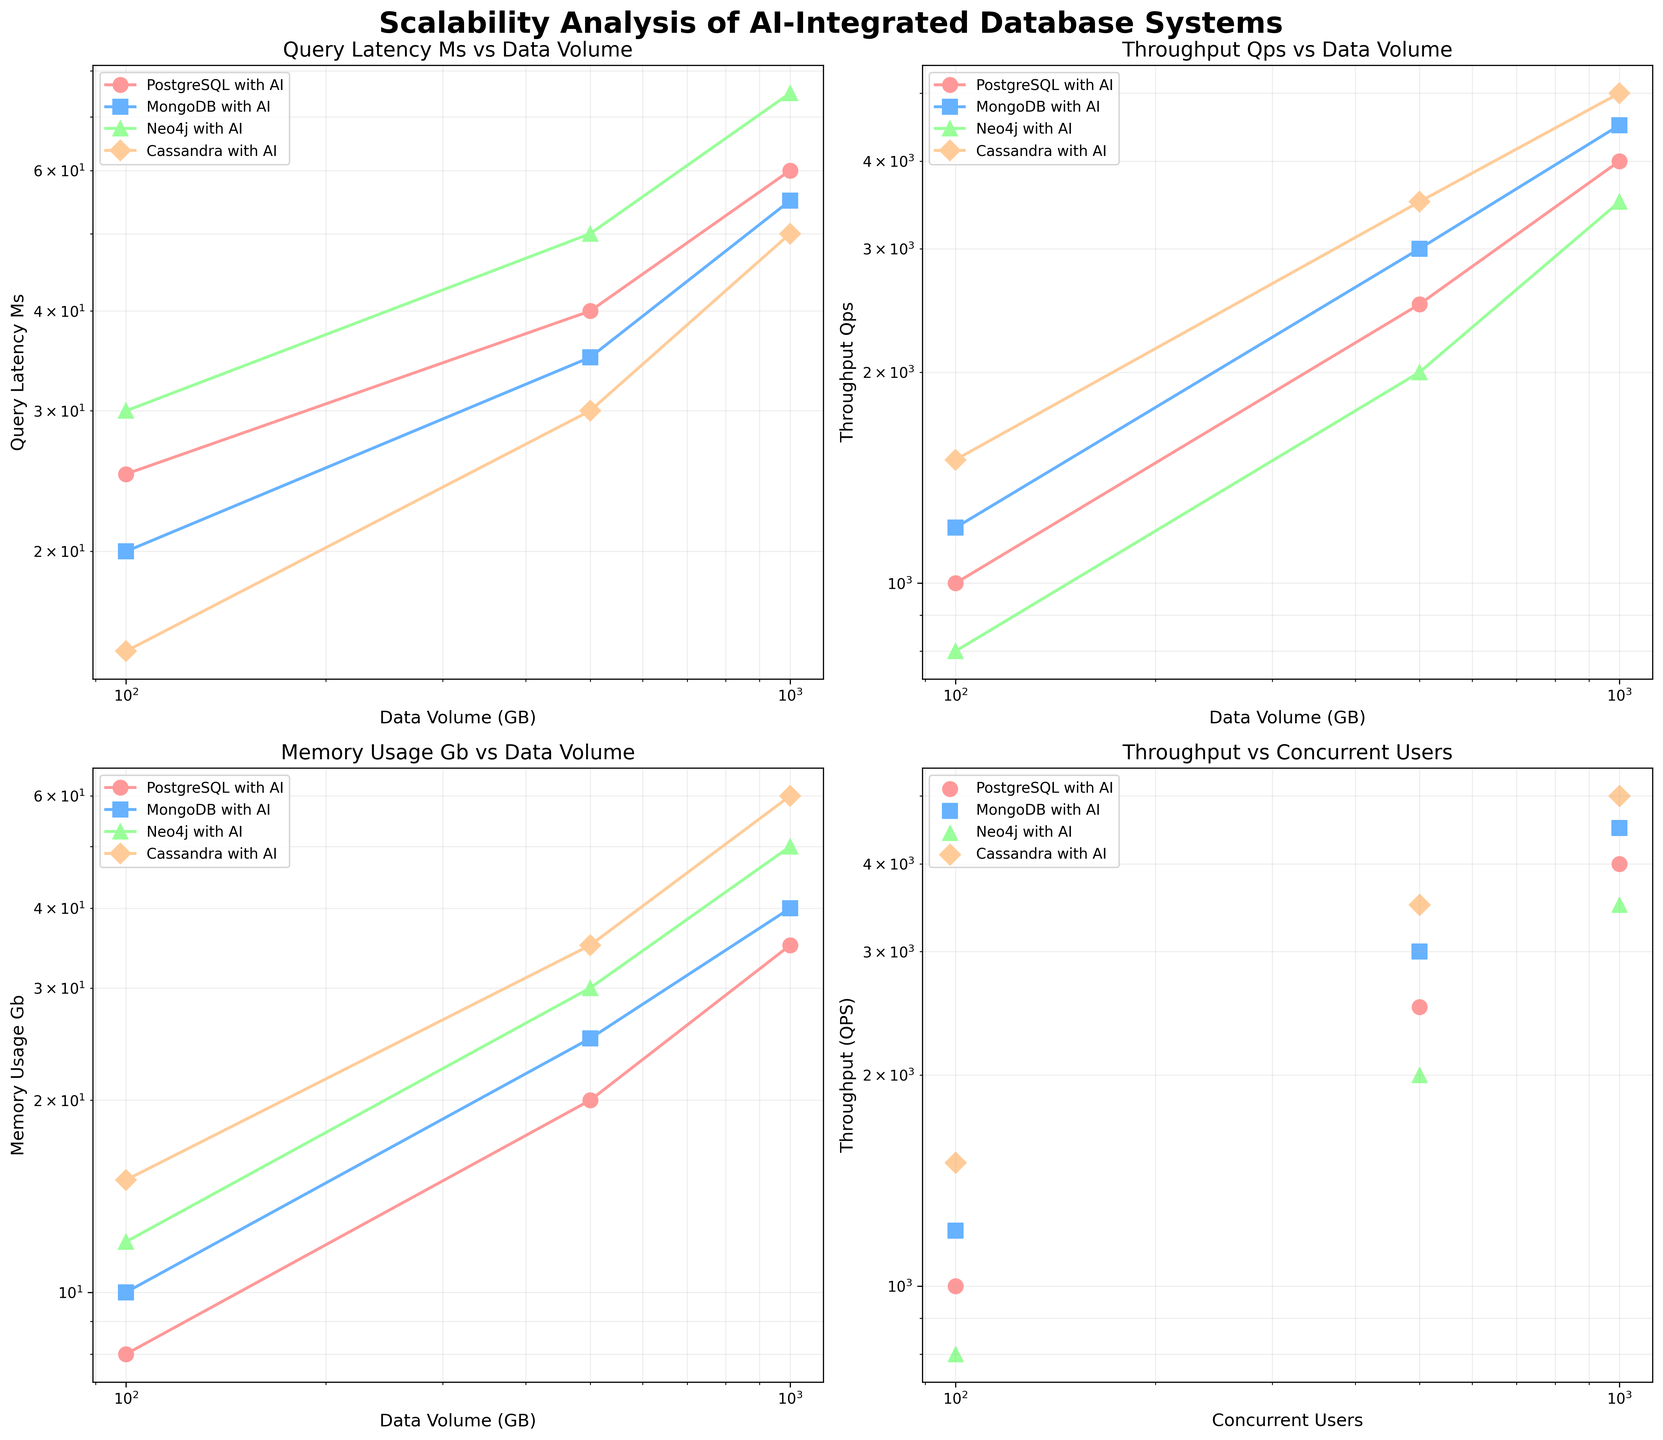What's the title of the overall figure? The title is located at the top center of the overall figure. It reads "Scalability Analysis of AI-Integrated Database Systems."
Answer: Scalability Analysis of AI-Integrated Database Systems Which database system has the lowest query latency for 1000 GB of data? By examining the "Query Latency (ms) vs Data Volume (GB)" subplot, look for the points associated with 1000 GB of data. Cassandra with AI has the lowest query latency at this data volume.
Answer: Cassandra with AI What is the throughput of MongoDB with AI for 500 concurrent users? Check the "Throughput (QPS) vs Concurrent Users" subplot and locate the point for MongoDB with AI at 500 concurrent users. The throughput is 3000 QPS.
Answer: 3000 QPS Which database system exhibits the highest memory usage when handling 100 GB of data? Refer to the "Memory Usage (GB) vs Data Volume (GB)" subplot, and identify the data points at 100 GB for each database system. Neo4j with AI shows the highest memory usage at 12 GB.
Answer: Neo4j with AI How does the query latency of Neo4j with AI compare to PostgreSQL with AI at 500 GB of data volume? In the "Query Latency (ms) vs Data Volume (GB)" subplot, compare the latency values for Neo4j with AI and PostgreSQL with AI at 500 GB. Neo4j with AI has a higher latency of 50 ms compared to PostgreSQL with AI, which has 40 ms.
Answer: Neo4j with AI has higher latency What trend do you observe in the throughput of Cassandra with AI as the data volume increases from 100 GB to 1000 GB? Refer to the "Throughput (QPS) vs Data Volume (GB)" subplot and observe the points for Cassandra with AI. There's a consistent increase in throughput from 1500 QPS at 100 GB to 5000 QPS at 1000 GB.
Answer: Increasing trend Between PostgreSQL with AI and MongoDB with AI, which system demonstrates better scalability in terms of throughput with increasing users? Examine the "Throughput (QPS) vs Concurrent Users" subplot for both systems. MongoDB with AI demonstrates better scalability since its increase from 1200 to 4500 QPS is greater relative to PostgreSQL with AI, which goes from 1000 to 4000 QPS.
Answer: MongoDB with AI What's the ratio of memory usage between 1000 GB and 100 GB for Cassandra with AI? In the "Memory Usage (GB) vs Data Volume (GB)" subplot, find the memory usage for Cassandra with AI at 1000 GB (60 GB) and 100 GB (15 GB). The ratio is 60/15, which simplifies to 4.
Answer: 4 Among the four database systems, which one has the least variation in query latency as data volume increases? By inspecting the "Query Latency (ms) vs Data Volume (GB)" subplot, analyzing the spread of the data points across data volumes, Cassandra with AI shows the least variation in query latency.
Answer: Cassandra with AI How does the memory usage of PostgreSQL with AI compare to Neo4j with AI at 1000 GB? On the "Memory Usage (GB) vs Data Volume (GB)" subplot, compare the points for 1000 GB. PostgreSQL with AI uses 35 GB of memory, while Neo4j with AI uses 50 GB, so PostgreSQL with AI has lower memory usage.
Answer: PostgreSQL with AI 